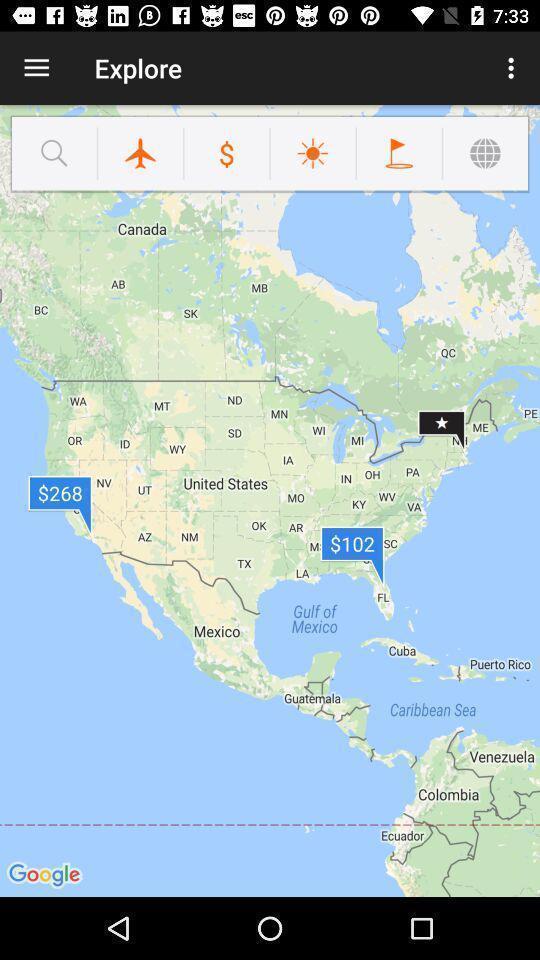Explain what's happening in this screen capture. Screen shows multiple options in a travel application. 